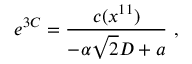<formula> <loc_0><loc_0><loc_500><loc_500>e ^ { 3 C } = { \frac { c ( x ^ { 1 1 } ) } { - \alpha \sqrt { 2 } D + a } } \ ,</formula> 